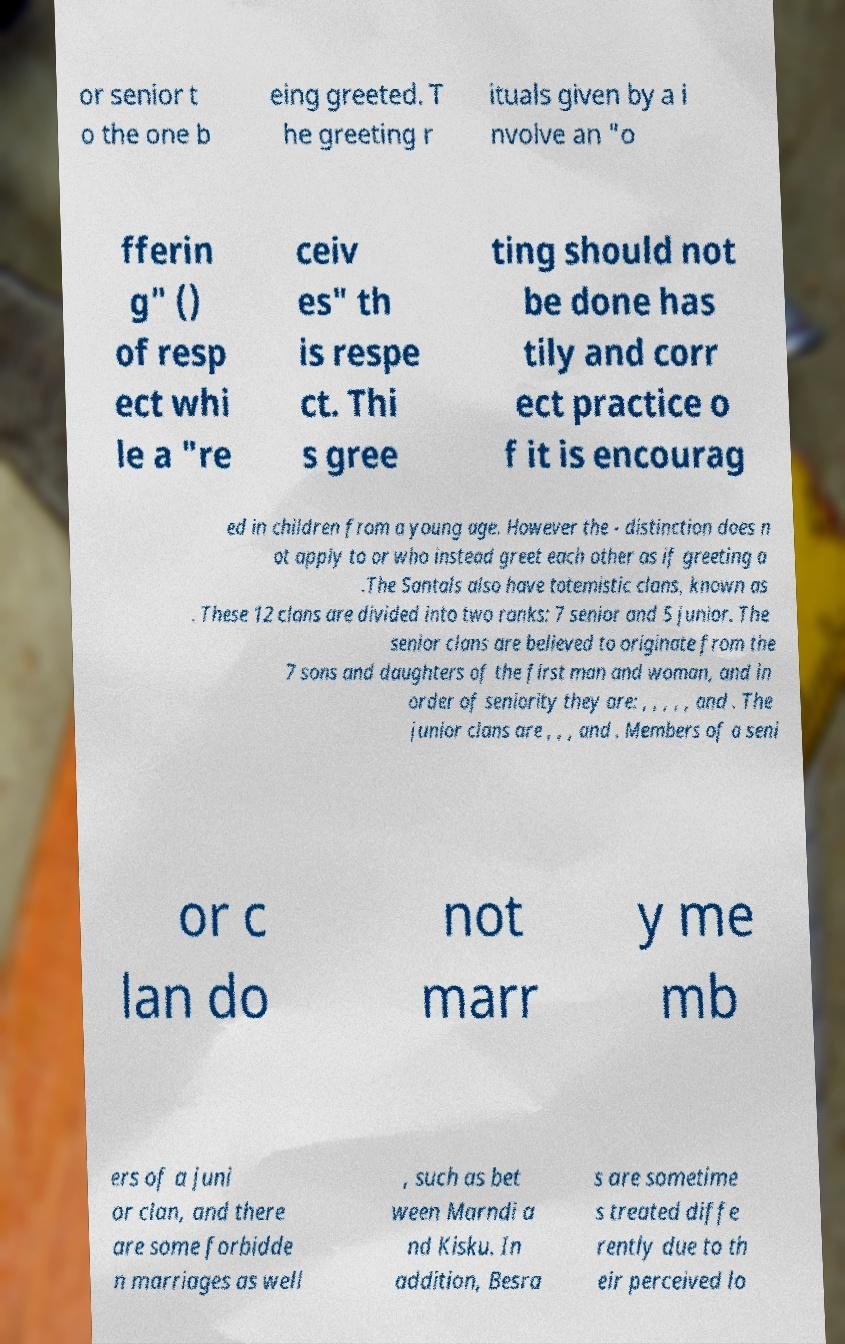I need the written content from this picture converted into text. Can you do that? or senior t o the one b eing greeted. T he greeting r ituals given by a i nvolve an "o fferin g" () of resp ect whi le a "re ceiv es" th is respe ct. Thi s gree ting should not be done has tily and corr ect practice o f it is encourag ed in children from a young age. However the - distinction does n ot apply to or who instead greet each other as if greeting a .The Santals also have totemistic clans, known as . These 12 clans are divided into two ranks: 7 senior and 5 junior. The senior clans are believed to originate from the 7 sons and daughters of the first man and woman, and in order of seniority they are: , , , , , and . The junior clans are , , , and . Members of a seni or c lan do not marr y me mb ers of a juni or clan, and there are some forbidde n marriages as well , such as bet ween Marndi a nd Kisku. In addition, Besra s are sometime s treated diffe rently due to th eir perceived lo 